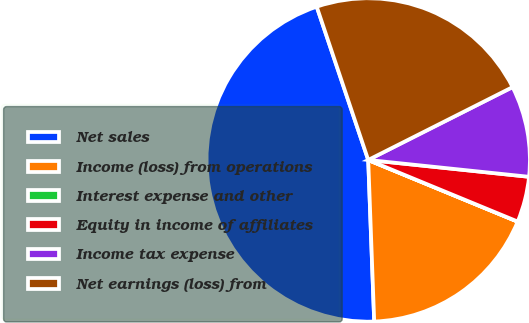<chart> <loc_0><loc_0><loc_500><loc_500><pie_chart><fcel>Net sales<fcel>Income (loss) from operations<fcel>Interest expense and other<fcel>Equity in income of affiliates<fcel>Income tax expense<fcel>Net earnings (loss) from<nl><fcel>45.43%<fcel>18.18%<fcel>0.01%<fcel>4.56%<fcel>9.1%<fcel>22.72%<nl></chart> 